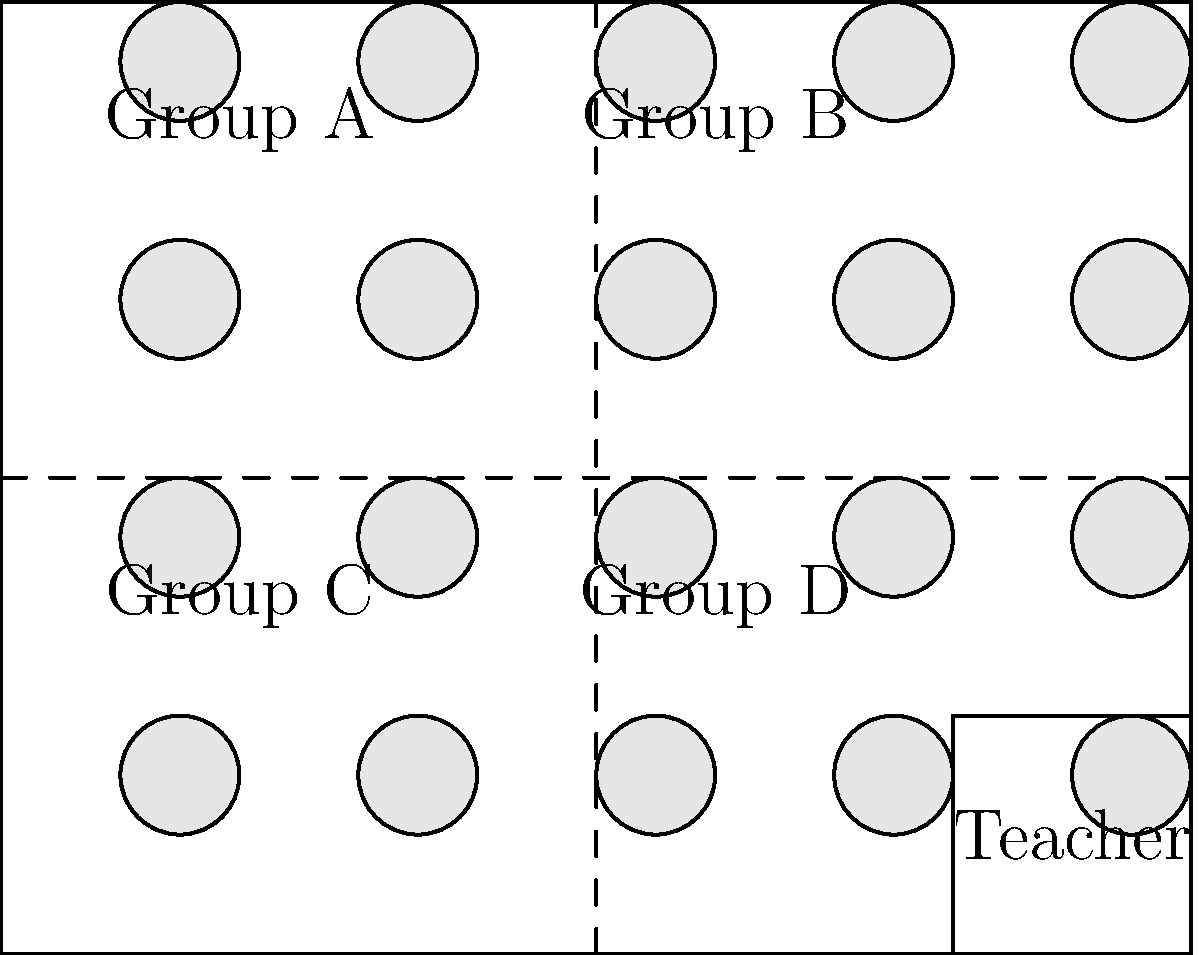In the classroom seating chart shown above, which group arrangement would be most beneficial for a student with social anxiety who struggles with large group interactions but needs support from peers? To determine the most beneficial group arrangement for a student with social anxiety, we need to consider several factors:

1. Group size: Smaller groups are generally less overwhelming for students with social anxiety.
2. Peer support: Having supportive peers nearby can help the anxious student feel more comfortable.
3. Teacher proximity: Being closer to the teacher can provide a sense of security and easier access to help.

Analyzing the seating chart:

1. The classroom is divided into four groups: A, B, C, and D.
2. Each group consists of 5 students (5 desks per group).
3. The teacher's desk is located in the bottom right corner.

Considering these factors:

- Group A and B are further from the teacher, which may not provide the desired level of support.
- Group C and D are closer to the teacher, offering easier access to adult guidance.
- All groups have the same number of students, so group size is not a differentiating factor.

The best option would be Group D because:
1. It is close to the teacher, providing easy access to adult support.
2. It allows for peer interactions in a structured small group setting.
3. It's positioned in a way that the anxious student can observe most of the classroom without feeling exposed.

This arrangement allows the student to gradually build confidence in social interactions while having both peer and teacher support readily available.
Answer: Group D 